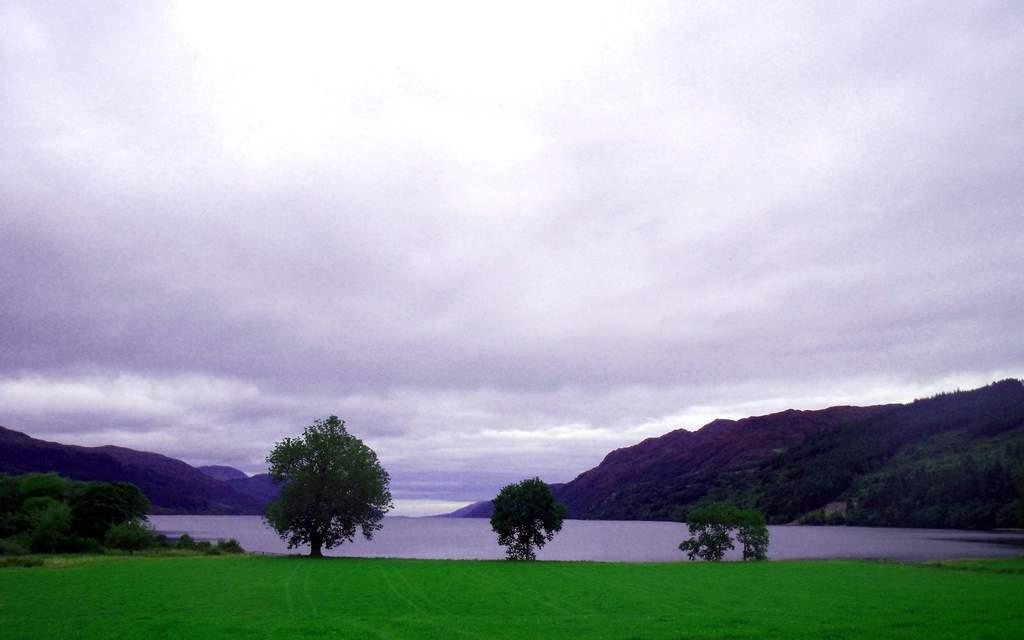How would you summarize this image in a sentence or two? In this picture I can observe some grass and trees on the ground. I can observe a river in the bottom of the picture. On either sides of the picture there are hills. In the background I can observe some clouds in the sky. 